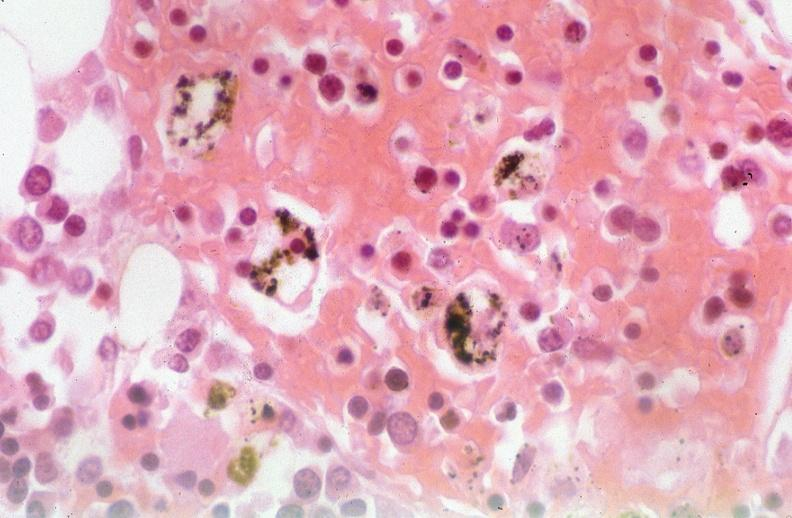was macerated stillborn used to sclerose emphysematous lung, alpha-1 antitrypsin deficiency?
Answer the question using a single word or phrase. No 